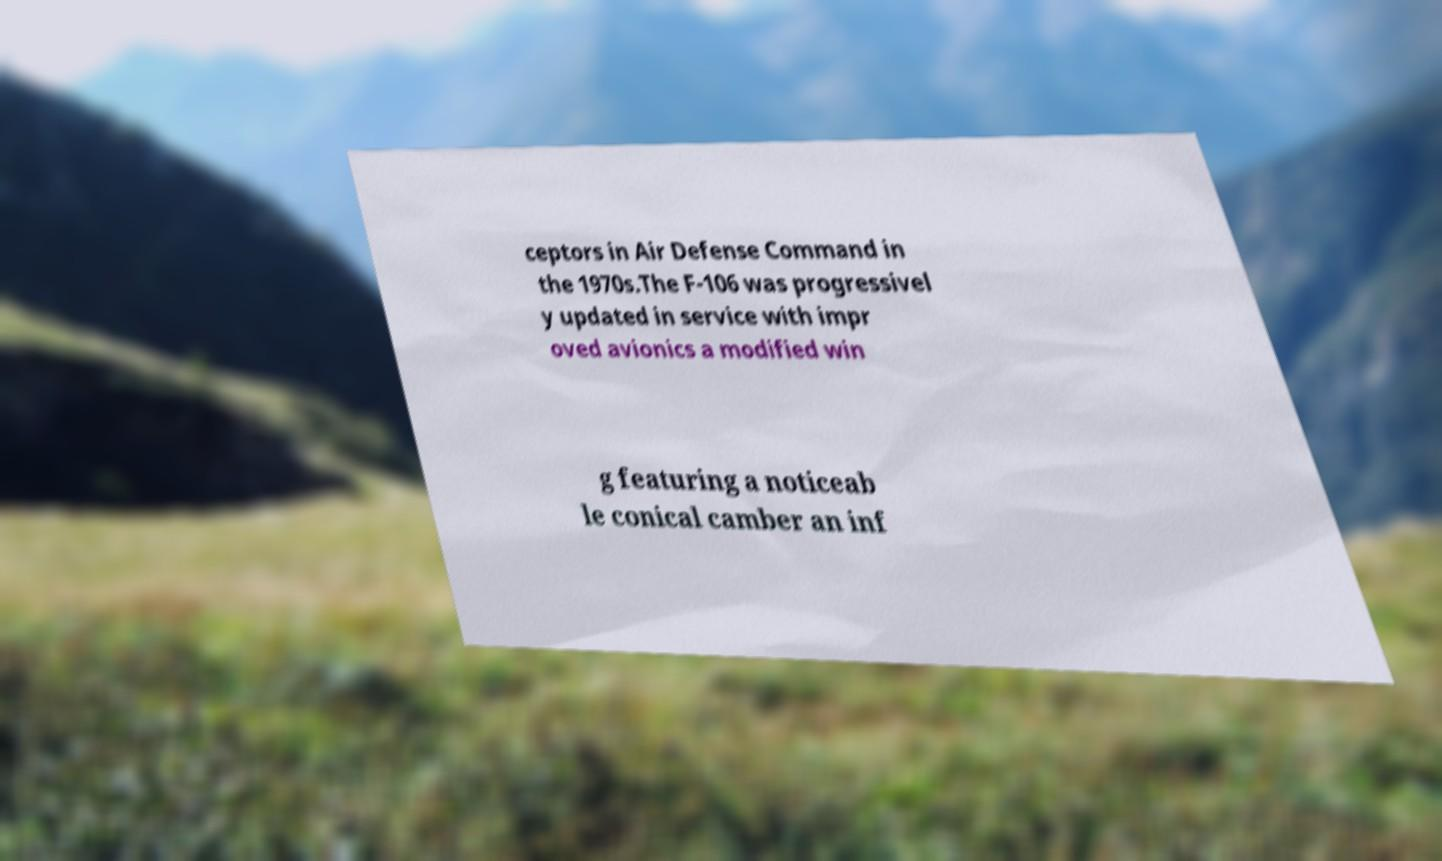Please read and relay the text visible in this image. What does it say? ceptors in Air Defense Command in the 1970s.The F-106 was progressivel y updated in service with impr oved avionics a modified win g featuring a noticeab le conical camber an inf 